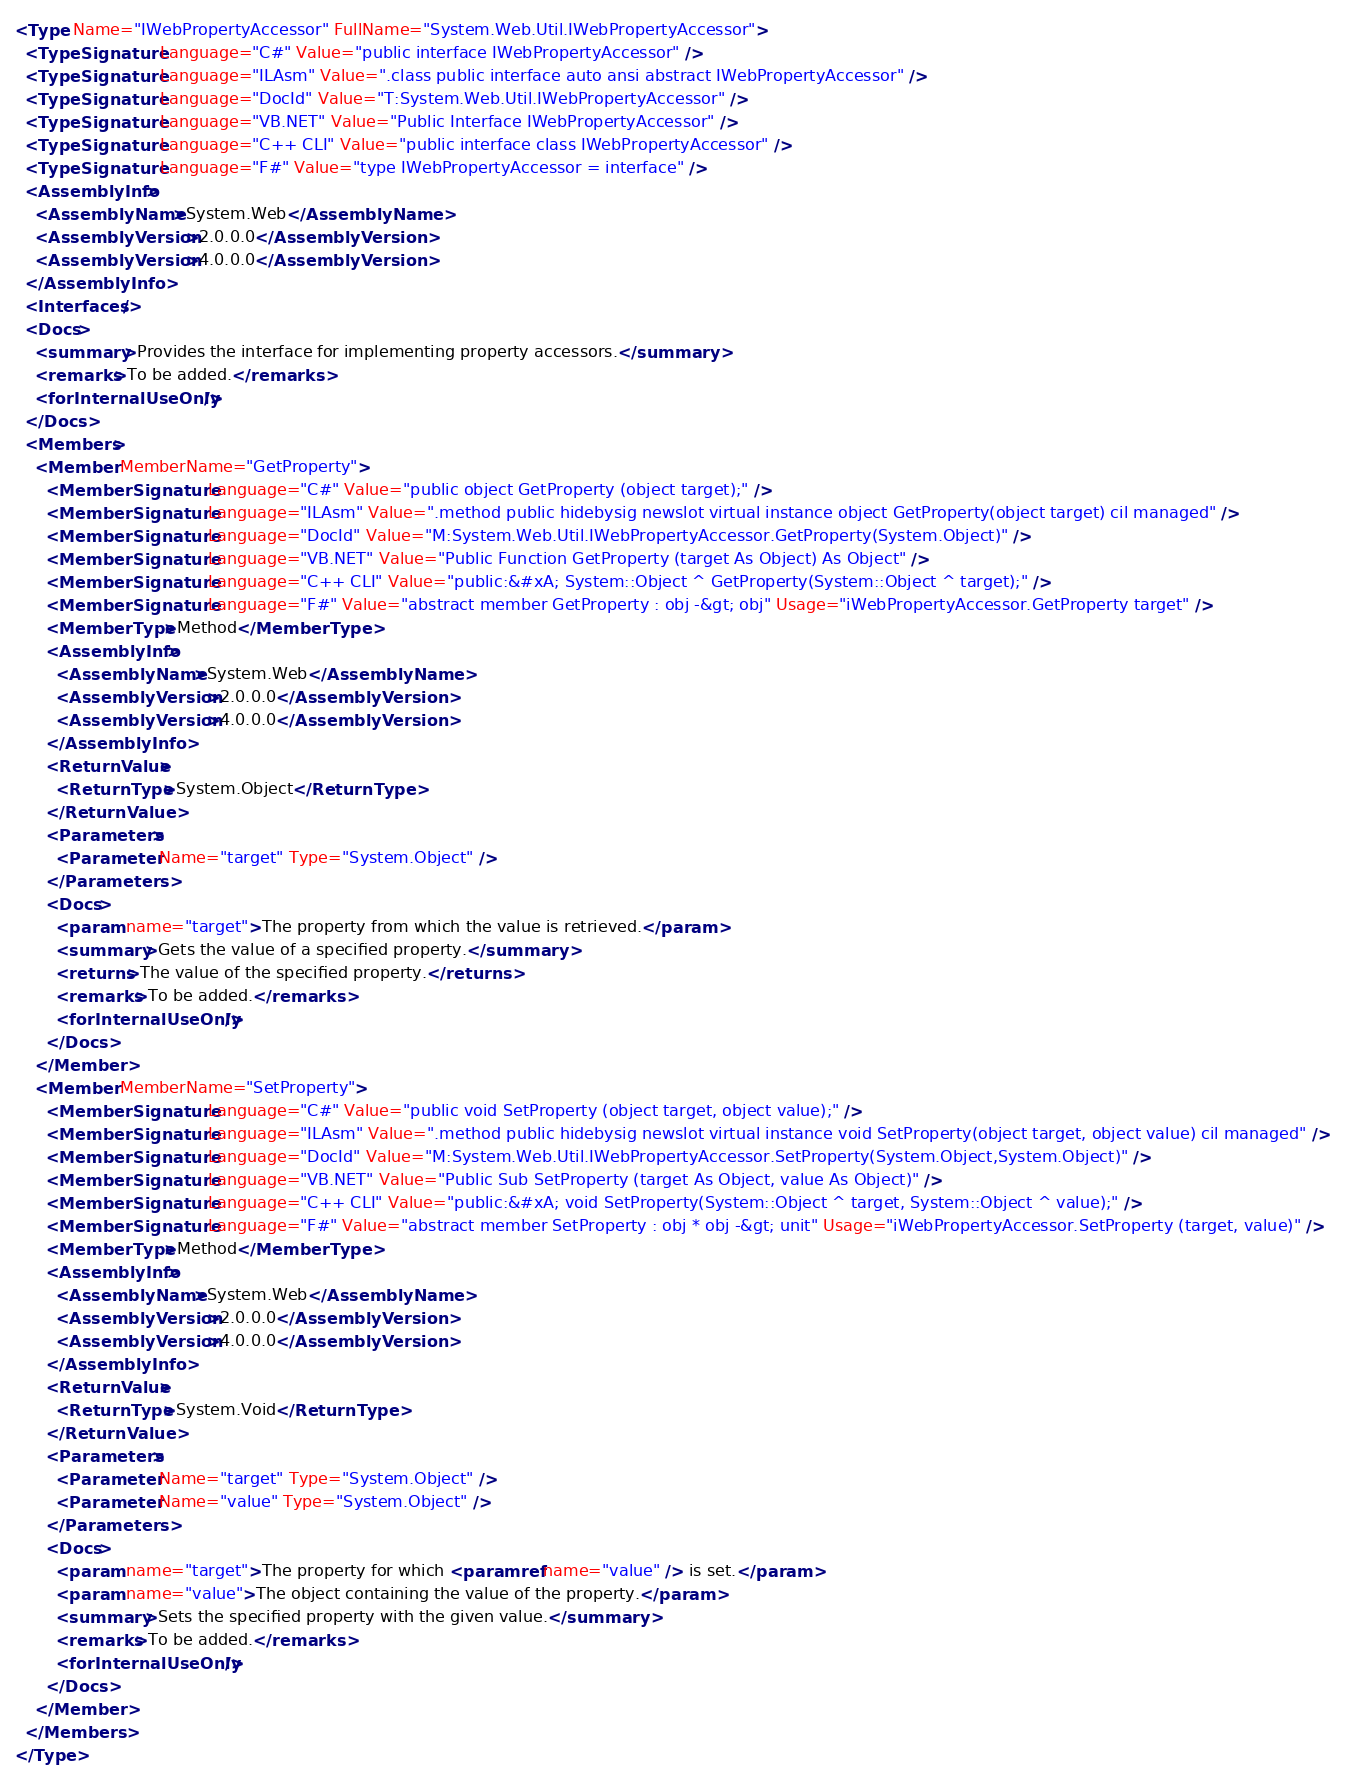<code> <loc_0><loc_0><loc_500><loc_500><_XML_><Type Name="IWebPropertyAccessor" FullName="System.Web.Util.IWebPropertyAccessor">
  <TypeSignature Language="C#" Value="public interface IWebPropertyAccessor" />
  <TypeSignature Language="ILAsm" Value=".class public interface auto ansi abstract IWebPropertyAccessor" />
  <TypeSignature Language="DocId" Value="T:System.Web.Util.IWebPropertyAccessor" />
  <TypeSignature Language="VB.NET" Value="Public Interface IWebPropertyAccessor" />
  <TypeSignature Language="C++ CLI" Value="public interface class IWebPropertyAccessor" />
  <TypeSignature Language="F#" Value="type IWebPropertyAccessor = interface" />
  <AssemblyInfo>
    <AssemblyName>System.Web</AssemblyName>
    <AssemblyVersion>2.0.0.0</AssemblyVersion>
    <AssemblyVersion>4.0.0.0</AssemblyVersion>
  </AssemblyInfo>
  <Interfaces />
  <Docs>
    <summary>Provides the interface for implementing property accessors.</summary>
    <remarks>To be added.</remarks>
    <forInternalUseOnly />
  </Docs>
  <Members>
    <Member MemberName="GetProperty">
      <MemberSignature Language="C#" Value="public object GetProperty (object target);" />
      <MemberSignature Language="ILAsm" Value=".method public hidebysig newslot virtual instance object GetProperty(object target) cil managed" />
      <MemberSignature Language="DocId" Value="M:System.Web.Util.IWebPropertyAccessor.GetProperty(System.Object)" />
      <MemberSignature Language="VB.NET" Value="Public Function GetProperty (target As Object) As Object" />
      <MemberSignature Language="C++ CLI" Value="public:&#xA; System::Object ^ GetProperty(System::Object ^ target);" />
      <MemberSignature Language="F#" Value="abstract member GetProperty : obj -&gt; obj" Usage="iWebPropertyAccessor.GetProperty target" />
      <MemberType>Method</MemberType>
      <AssemblyInfo>
        <AssemblyName>System.Web</AssemblyName>
        <AssemblyVersion>2.0.0.0</AssemblyVersion>
        <AssemblyVersion>4.0.0.0</AssemblyVersion>
      </AssemblyInfo>
      <ReturnValue>
        <ReturnType>System.Object</ReturnType>
      </ReturnValue>
      <Parameters>
        <Parameter Name="target" Type="System.Object" />
      </Parameters>
      <Docs>
        <param name="target">The property from which the value is retrieved.</param>
        <summary>Gets the value of a specified property.</summary>
        <returns>The value of the specified property.</returns>
        <remarks>To be added.</remarks>
        <forInternalUseOnly />
      </Docs>
    </Member>
    <Member MemberName="SetProperty">
      <MemberSignature Language="C#" Value="public void SetProperty (object target, object value);" />
      <MemberSignature Language="ILAsm" Value=".method public hidebysig newslot virtual instance void SetProperty(object target, object value) cil managed" />
      <MemberSignature Language="DocId" Value="M:System.Web.Util.IWebPropertyAccessor.SetProperty(System.Object,System.Object)" />
      <MemberSignature Language="VB.NET" Value="Public Sub SetProperty (target As Object, value As Object)" />
      <MemberSignature Language="C++ CLI" Value="public:&#xA; void SetProperty(System::Object ^ target, System::Object ^ value);" />
      <MemberSignature Language="F#" Value="abstract member SetProperty : obj * obj -&gt; unit" Usage="iWebPropertyAccessor.SetProperty (target, value)" />
      <MemberType>Method</MemberType>
      <AssemblyInfo>
        <AssemblyName>System.Web</AssemblyName>
        <AssemblyVersion>2.0.0.0</AssemblyVersion>
        <AssemblyVersion>4.0.0.0</AssemblyVersion>
      </AssemblyInfo>
      <ReturnValue>
        <ReturnType>System.Void</ReturnType>
      </ReturnValue>
      <Parameters>
        <Parameter Name="target" Type="System.Object" />
        <Parameter Name="value" Type="System.Object" />
      </Parameters>
      <Docs>
        <param name="target">The property for which <paramref name="value" /> is set.</param>
        <param name="value">The object containing the value of the property.</param>
        <summary>Sets the specified property with the given value.</summary>
        <remarks>To be added.</remarks>
        <forInternalUseOnly />
      </Docs>
    </Member>
  </Members>
</Type>
</code> 